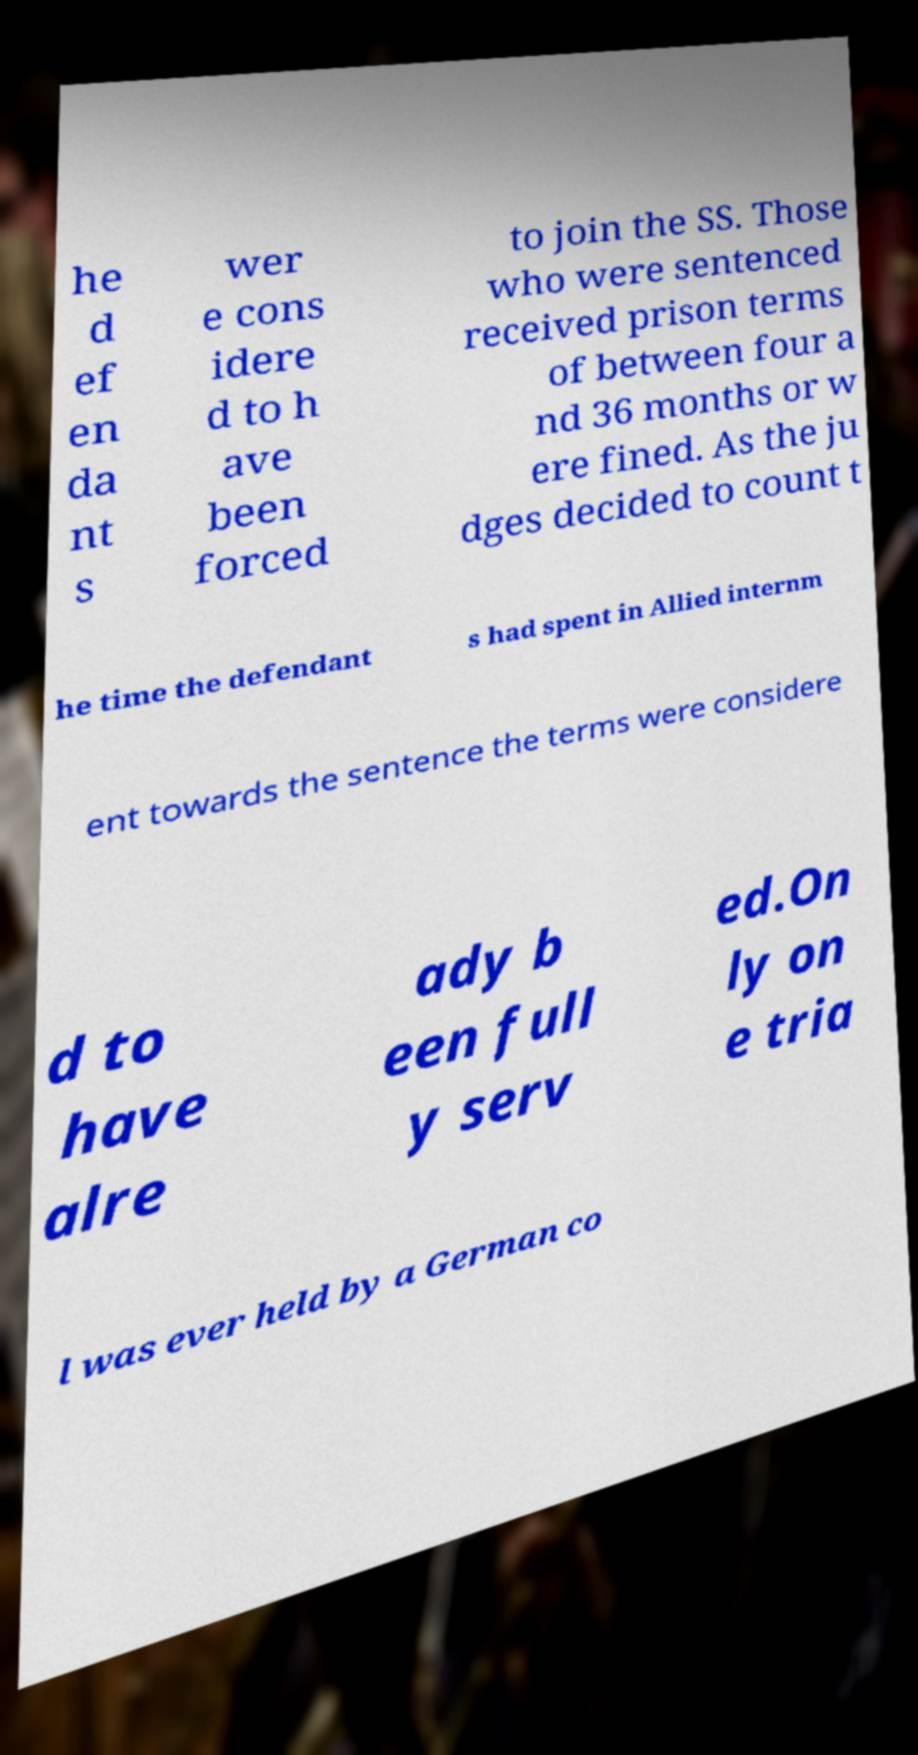What messages or text are displayed in this image? I need them in a readable, typed format. he d ef en da nt s wer e cons idere d to h ave been forced to join the SS. Those who were sentenced received prison terms of between four a nd 36 months or w ere fined. As the ju dges decided to count t he time the defendant s had spent in Allied internm ent towards the sentence the terms were considere d to have alre ady b een full y serv ed.On ly on e tria l was ever held by a German co 